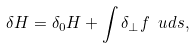<formula> <loc_0><loc_0><loc_500><loc_500>\delta H = \delta _ { 0 } H + \int \delta _ { \perp } f \, \ u d s ,</formula> 